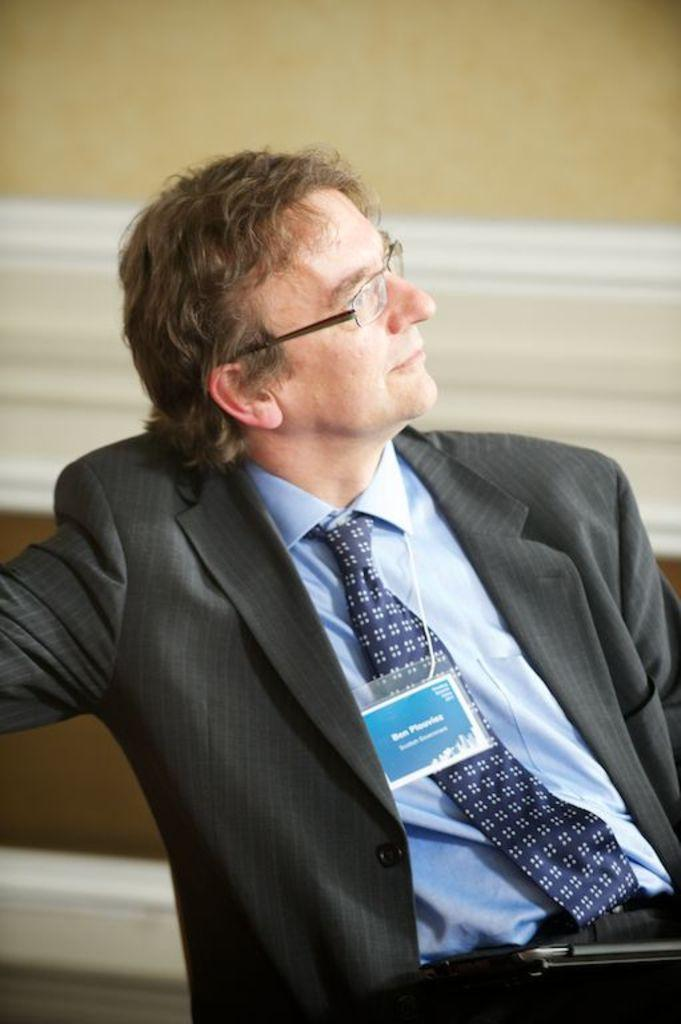What is the man in the image wearing? The man is wearing spectacles, a blazer, a shirt, a tie, and trousers. What is the man holding in the image? The man is holding a laptop. What can be seen in the background of the image? There is a wall in the background of the image. What is the man's facial expression in the image? The man is smiling in the image. Can you tell me how much debt the man is in, based on the image? There is no information about the man's debt in the image. 